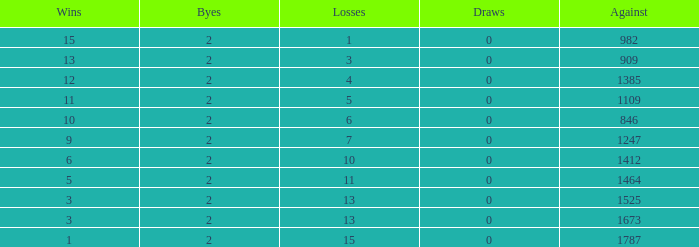What is the highest number listed under against when there were 15 losses and more than 1 win? None. 